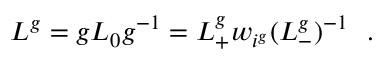Convert formula to latex. <formula><loc_0><loc_0><loc_500><loc_500>L ^ { g } = g L _ { 0 } g ^ { - 1 } = L _ { + } ^ { g } w _ { i ^ { g } } ( L _ { - } ^ { g } ) ^ { - 1 } \ \ .</formula> 